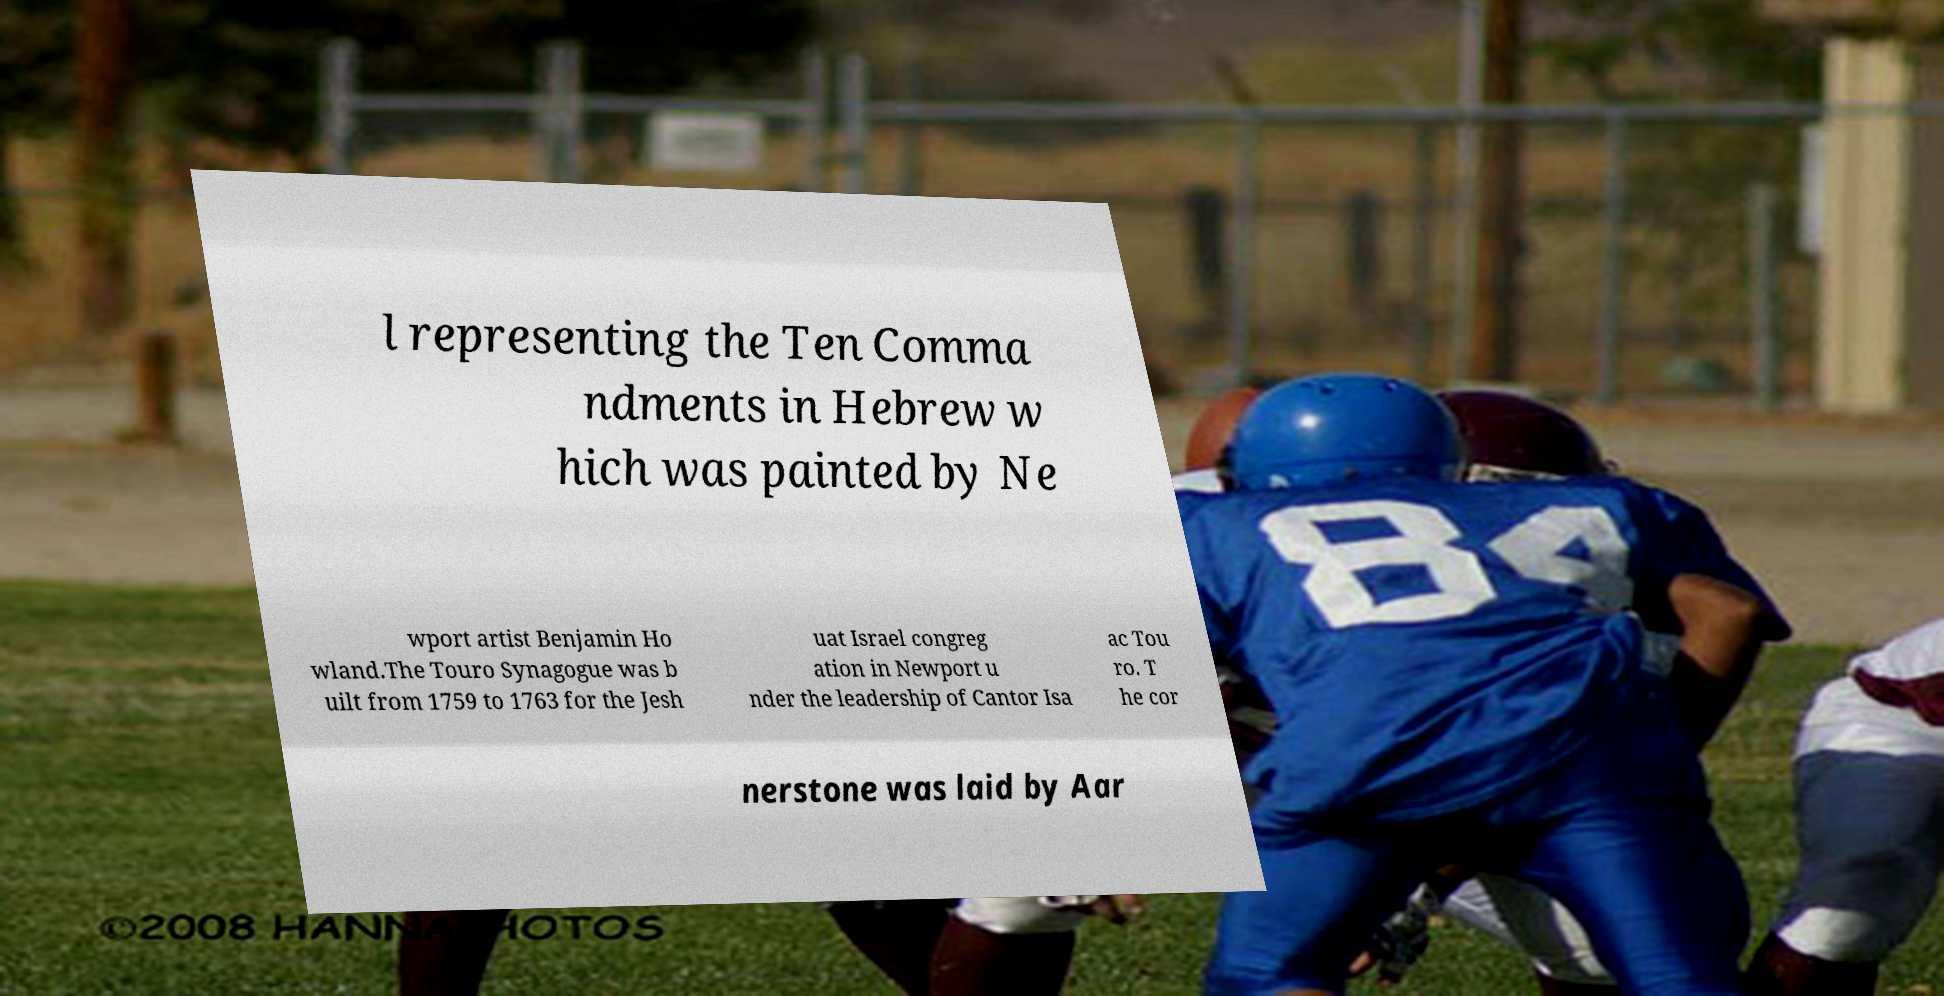What messages or text are displayed in this image? I need them in a readable, typed format. l representing the Ten Comma ndments in Hebrew w hich was painted by Ne wport artist Benjamin Ho wland.The Touro Synagogue was b uilt from 1759 to 1763 for the Jesh uat Israel congreg ation in Newport u nder the leadership of Cantor Isa ac Tou ro. T he cor nerstone was laid by Aar 